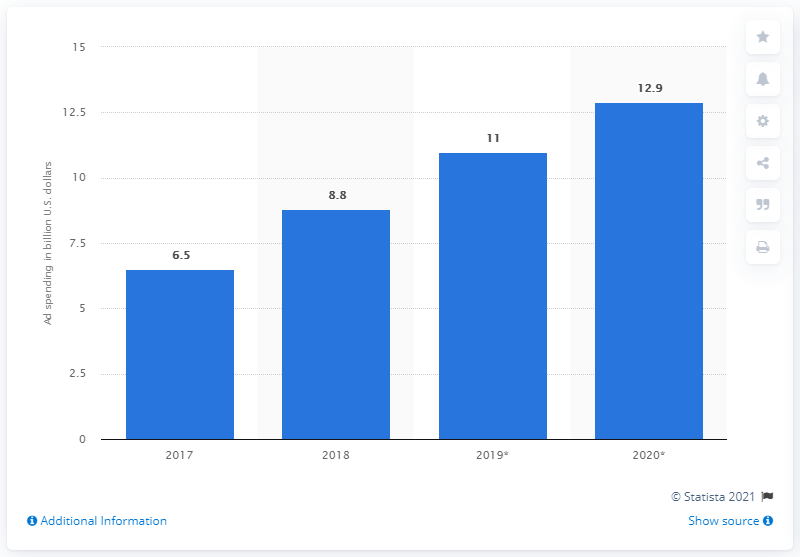Point out several critical features in this image. In 2020, the estimated amount of mobile app install advertising expenditures is projected to be 12.9. In 2017, the total amount of mobile app install advertising expenditures in North America was $6.5 billion. 